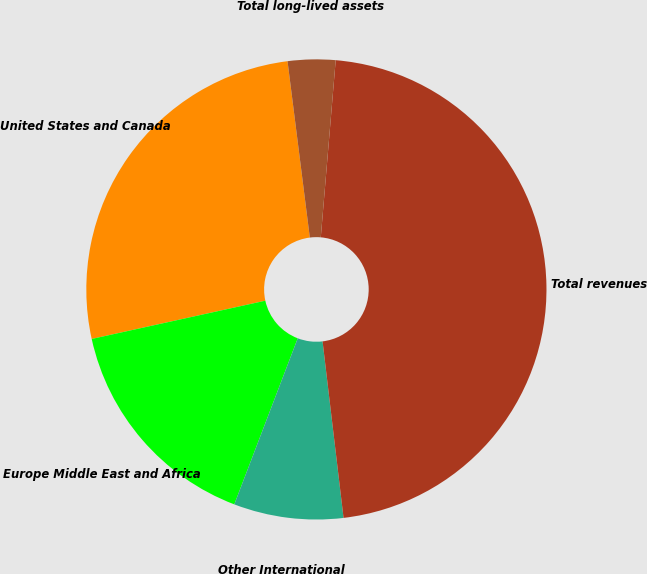Convert chart. <chart><loc_0><loc_0><loc_500><loc_500><pie_chart><fcel>United States and Canada<fcel>Europe Middle East and Africa<fcel>Other International<fcel>Total revenues<fcel>Total long-lived assets<nl><fcel>26.45%<fcel>15.74%<fcel>7.69%<fcel>46.78%<fcel>3.34%<nl></chart> 